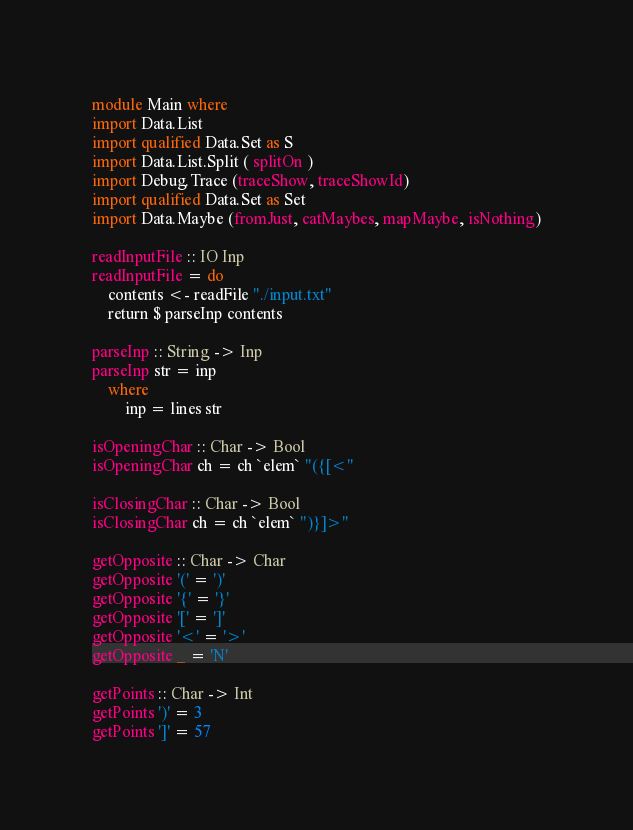Convert code to text. <code><loc_0><loc_0><loc_500><loc_500><_Haskell_>module Main where
import Data.List
import qualified Data.Set as S
import Data.List.Split ( splitOn )
import Debug.Trace (traceShow, traceShowId)
import qualified Data.Set as Set
import Data.Maybe (fromJust, catMaybes, mapMaybe, isNothing)

readInputFile :: IO Inp
readInputFile = do
    contents <- readFile "./input.txt"
    return $ parseInp contents

parseInp :: String -> Inp
parseInp str = inp
    where
        inp = lines str

isOpeningChar :: Char -> Bool
isOpeningChar ch = ch `elem` "({[<"

isClosingChar :: Char -> Bool
isClosingChar ch = ch `elem` ")}]>"

getOpposite :: Char -> Char
getOpposite '(' = ')'
getOpposite '{' = '}'
getOpposite '[' = ']'
getOpposite '<' = '>'
getOpposite _ = 'N'

getPoints :: Char -> Int
getPoints ')' = 3
getPoints ']' = 57</code> 